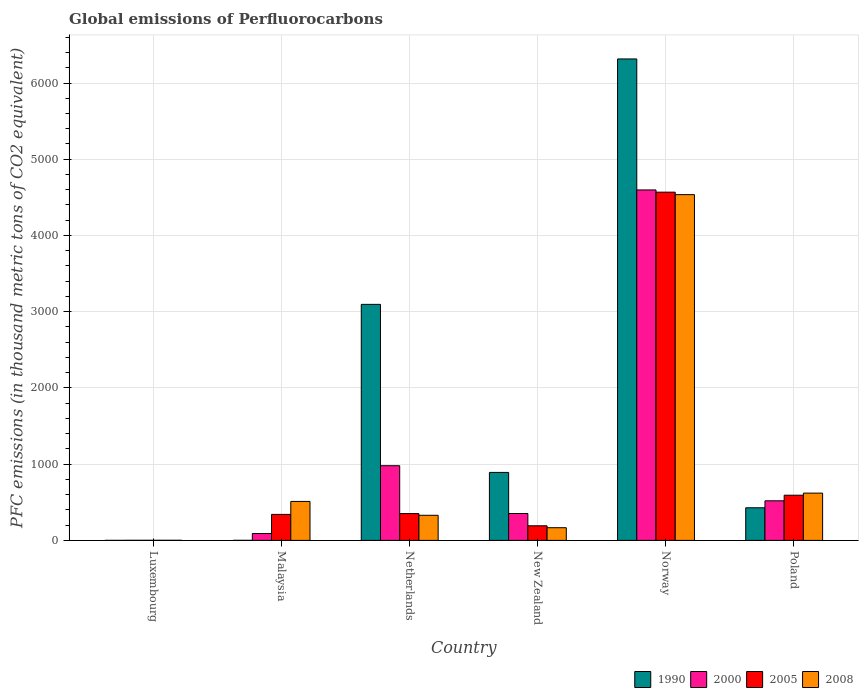How many different coloured bars are there?
Your answer should be compact. 4. How many groups of bars are there?
Provide a succinct answer. 6. Are the number of bars on each tick of the X-axis equal?
Give a very brief answer. Yes. How many bars are there on the 6th tick from the left?
Offer a very short reply. 4. How many bars are there on the 6th tick from the right?
Your response must be concise. 4. What is the label of the 4th group of bars from the left?
Provide a succinct answer. New Zealand. In how many cases, is the number of bars for a given country not equal to the number of legend labels?
Give a very brief answer. 0. What is the global emissions of Perfluorocarbons in 2008 in Norway?
Offer a terse response. 4535.7. Across all countries, what is the maximum global emissions of Perfluorocarbons in 1990?
Your response must be concise. 6315.7. Across all countries, what is the minimum global emissions of Perfluorocarbons in 2000?
Provide a short and direct response. 1. In which country was the global emissions of Perfluorocarbons in 2008 minimum?
Your answer should be compact. Luxembourg. What is the total global emissions of Perfluorocarbons in 2005 in the graph?
Give a very brief answer. 6045.8. What is the difference between the global emissions of Perfluorocarbons in 2005 in Luxembourg and that in New Zealand?
Offer a very short reply. -190.5. What is the difference between the global emissions of Perfluorocarbons in 2005 in Malaysia and the global emissions of Perfluorocarbons in 2008 in Luxembourg?
Your answer should be very brief. 339.7. What is the average global emissions of Perfluorocarbons in 2005 per country?
Offer a very short reply. 1007.63. What is the difference between the global emissions of Perfluorocarbons of/in 1990 and global emissions of Perfluorocarbons of/in 2008 in Poland?
Ensure brevity in your answer.  -192.3. What is the ratio of the global emissions of Perfluorocarbons in 2005 in Luxembourg to that in Malaysia?
Your response must be concise. 0. Is the difference between the global emissions of Perfluorocarbons in 1990 in Malaysia and Poland greater than the difference between the global emissions of Perfluorocarbons in 2008 in Malaysia and Poland?
Provide a short and direct response. No. What is the difference between the highest and the second highest global emissions of Perfluorocarbons in 1990?
Give a very brief answer. 2204.4. What is the difference between the highest and the lowest global emissions of Perfluorocarbons in 2000?
Your answer should be compact. 4596.3. Is the sum of the global emissions of Perfluorocarbons in 1990 in Luxembourg and Netherlands greater than the maximum global emissions of Perfluorocarbons in 2000 across all countries?
Your response must be concise. No. What does the 1st bar from the left in Poland represents?
Give a very brief answer. 1990. Is it the case that in every country, the sum of the global emissions of Perfluorocarbons in 2000 and global emissions of Perfluorocarbons in 2008 is greater than the global emissions of Perfluorocarbons in 2005?
Make the answer very short. Yes. How many bars are there?
Your answer should be very brief. 24. How many countries are there in the graph?
Offer a terse response. 6. What is the difference between two consecutive major ticks on the Y-axis?
Keep it short and to the point. 1000. Are the values on the major ticks of Y-axis written in scientific E-notation?
Offer a terse response. No. How are the legend labels stacked?
Make the answer very short. Horizontal. What is the title of the graph?
Keep it short and to the point. Global emissions of Perfluorocarbons. What is the label or title of the Y-axis?
Provide a short and direct response. PFC emissions (in thousand metric tons of CO2 equivalent). What is the PFC emissions (in thousand metric tons of CO2 equivalent) of 2008 in Luxembourg?
Provide a short and direct response. 1.2. What is the PFC emissions (in thousand metric tons of CO2 equivalent) of 2000 in Malaysia?
Your response must be concise. 90.1. What is the PFC emissions (in thousand metric tons of CO2 equivalent) in 2005 in Malaysia?
Provide a short and direct response. 340.9. What is the PFC emissions (in thousand metric tons of CO2 equivalent) of 2008 in Malaysia?
Make the answer very short. 511. What is the PFC emissions (in thousand metric tons of CO2 equivalent) of 1990 in Netherlands?
Give a very brief answer. 3096.2. What is the PFC emissions (in thousand metric tons of CO2 equivalent) in 2000 in Netherlands?
Offer a terse response. 979.5. What is the PFC emissions (in thousand metric tons of CO2 equivalent) of 2005 in Netherlands?
Keep it short and to the point. 351.4. What is the PFC emissions (in thousand metric tons of CO2 equivalent) in 2008 in Netherlands?
Give a very brief answer. 329.2. What is the PFC emissions (in thousand metric tons of CO2 equivalent) in 1990 in New Zealand?
Provide a short and direct response. 891.8. What is the PFC emissions (in thousand metric tons of CO2 equivalent) in 2000 in New Zealand?
Offer a very short reply. 352.6. What is the PFC emissions (in thousand metric tons of CO2 equivalent) of 2005 in New Zealand?
Your answer should be compact. 191.6. What is the PFC emissions (in thousand metric tons of CO2 equivalent) of 2008 in New Zealand?
Give a very brief answer. 166.4. What is the PFC emissions (in thousand metric tons of CO2 equivalent) of 1990 in Norway?
Provide a short and direct response. 6315.7. What is the PFC emissions (in thousand metric tons of CO2 equivalent) in 2000 in Norway?
Ensure brevity in your answer.  4597.3. What is the PFC emissions (in thousand metric tons of CO2 equivalent) of 2005 in Norway?
Give a very brief answer. 4568.1. What is the PFC emissions (in thousand metric tons of CO2 equivalent) in 2008 in Norway?
Ensure brevity in your answer.  4535.7. What is the PFC emissions (in thousand metric tons of CO2 equivalent) in 1990 in Poland?
Your answer should be very brief. 427.8. What is the PFC emissions (in thousand metric tons of CO2 equivalent) in 2000 in Poland?
Your answer should be compact. 519.3. What is the PFC emissions (in thousand metric tons of CO2 equivalent) of 2005 in Poland?
Provide a short and direct response. 592.7. What is the PFC emissions (in thousand metric tons of CO2 equivalent) in 2008 in Poland?
Offer a very short reply. 620.1. Across all countries, what is the maximum PFC emissions (in thousand metric tons of CO2 equivalent) in 1990?
Provide a succinct answer. 6315.7. Across all countries, what is the maximum PFC emissions (in thousand metric tons of CO2 equivalent) of 2000?
Give a very brief answer. 4597.3. Across all countries, what is the maximum PFC emissions (in thousand metric tons of CO2 equivalent) of 2005?
Offer a terse response. 4568.1. Across all countries, what is the maximum PFC emissions (in thousand metric tons of CO2 equivalent) in 2008?
Ensure brevity in your answer.  4535.7. Across all countries, what is the minimum PFC emissions (in thousand metric tons of CO2 equivalent) in 1990?
Give a very brief answer. 0.1. Across all countries, what is the minimum PFC emissions (in thousand metric tons of CO2 equivalent) in 2000?
Keep it short and to the point. 1. Across all countries, what is the minimum PFC emissions (in thousand metric tons of CO2 equivalent) of 2005?
Provide a short and direct response. 1.1. What is the total PFC emissions (in thousand metric tons of CO2 equivalent) in 1990 in the graph?
Provide a short and direct response. 1.07e+04. What is the total PFC emissions (in thousand metric tons of CO2 equivalent) of 2000 in the graph?
Make the answer very short. 6539.8. What is the total PFC emissions (in thousand metric tons of CO2 equivalent) in 2005 in the graph?
Your response must be concise. 6045.8. What is the total PFC emissions (in thousand metric tons of CO2 equivalent) in 2008 in the graph?
Provide a short and direct response. 6163.6. What is the difference between the PFC emissions (in thousand metric tons of CO2 equivalent) of 2000 in Luxembourg and that in Malaysia?
Your answer should be very brief. -89.1. What is the difference between the PFC emissions (in thousand metric tons of CO2 equivalent) in 2005 in Luxembourg and that in Malaysia?
Make the answer very short. -339.8. What is the difference between the PFC emissions (in thousand metric tons of CO2 equivalent) of 2008 in Luxembourg and that in Malaysia?
Provide a short and direct response. -509.8. What is the difference between the PFC emissions (in thousand metric tons of CO2 equivalent) of 1990 in Luxembourg and that in Netherlands?
Provide a short and direct response. -3096.1. What is the difference between the PFC emissions (in thousand metric tons of CO2 equivalent) of 2000 in Luxembourg and that in Netherlands?
Make the answer very short. -978.5. What is the difference between the PFC emissions (in thousand metric tons of CO2 equivalent) in 2005 in Luxembourg and that in Netherlands?
Keep it short and to the point. -350.3. What is the difference between the PFC emissions (in thousand metric tons of CO2 equivalent) in 2008 in Luxembourg and that in Netherlands?
Offer a terse response. -328. What is the difference between the PFC emissions (in thousand metric tons of CO2 equivalent) in 1990 in Luxembourg and that in New Zealand?
Ensure brevity in your answer.  -891.7. What is the difference between the PFC emissions (in thousand metric tons of CO2 equivalent) of 2000 in Luxembourg and that in New Zealand?
Keep it short and to the point. -351.6. What is the difference between the PFC emissions (in thousand metric tons of CO2 equivalent) of 2005 in Luxembourg and that in New Zealand?
Offer a terse response. -190.5. What is the difference between the PFC emissions (in thousand metric tons of CO2 equivalent) in 2008 in Luxembourg and that in New Zealand?
Your answer should be very brief. -165.2. What is the difference between the PFC emissions (in thousand metric tons of CO2 equivalent) of 1990 in Luxembourg and that in Norway?
Keep it short and to the point. -6315.6. What is the difference between the PFC emissions (in thousand metric tons of CO2 equivalent) of 2000 in Luxembourg and that in Norway?
Offer a terse response. -4596.3. What is the difference between the PFC emissions (in thousand metric tons of CO2 equivalent) of 2005 in Luxembourg and that in Norway?
Ensure brevity in your answer.  -4567. What is the difference between the PFC emissions (in thousand metric tons of CO2 equivalent) of 2008 in Luxembourg and that in Norway?
Keep it short and to the point. -4534.5. What is the difference between the PFC emissions (in thousand metric tons of CO2 equivalent) of 1990 in Luxembourg and that in Poland?
Your answer should be compact. -427.7. What is the difference between the PFC emissions (in thousand metric tons of CO2 equivalent) in 2000 in Luxembourg and that in Poland?
Provide a short and direct response. -518.3. What is the difference between the PFC emissions (in thousand metric tons of CO2 equivalent) of 2005 in Luxembourg and that in Poland?
Make the answer very short. -591.6. What is the difference between the PFC emissions (in thousand metric tons of CO2 equivalent) of 2008 in Luxembourg and that in Poland?
Give a very brief answer. -618.9. What is the difference between the PFC emissions (in thousand metric tons of CO2 equivalent) of 1990 in Malaysia and that in Netherlands?
Your answer should be very brief. -3095.6. What is the difference between the PFC emissions (in thousand metric tons of CO2 equivalent) in 2000 in Malaysia and that in Netherlands?
Offer a very short reply. -889.4. What is the difference between the PFC emissions (in thousand metric tons of CO2 equivalent) of 2005 in Malaysia and that in Netherlands?
Provide a short and direct response. -10.5. What is the difference between the PFC emissions (in thousand metric tons of CO2 equivalent) of 2008 in Malaysia and that in Netherlands?
Ensure brevity in your answer.  181.8. What is the difference between the PFC emissions (in thousand metric tons of CO2 equivalent) in 1990 in Malaysia and that in New Zealand?
Your response must be concise. -891.2. What is the difference between the PFC emissions (in thousand metric tons of CO2 equivalent) in 2000 in Malaysia and that in New Zealand?
Offer a very short reply. -262.5. What is the difference between the PFC emissions (in thousand metric tons of CO2 equivalent) of 2005 in Malaysia and that in New Zealand?
Provide a short and direct response. 149.3. What is the difference between the PFC emissions (in thousand metric tons of CO2 equivalent) of 2008 in Malaysia and that in New Zealand?
Offer a very short reply. 344.6. What is the difference between the PFC emissions (in thousand metric tons of CO2 equivalent) in 1990 in Malaysia and that in Norway?
Provide a short and direct response. -6315.1. What is the difference between the PFC emissions (in thousand metric tons of CO2 equivalent) of 2000 in Malaysia and that in Norway?
Your answer should be very brief. -4507.2. What is the difference between the PFC emissions (in thousand metric tons of CO2 equivalent) of 2005 in Malaysia and that in Norway?
Offer a terse response. -4227.2. What is the difference between the PFC emissions (in thousand metric tons of CO2 equivalent) in 2008 in Malaysia and that in Norway?
Your answer should be compact. -4024.7. What is the difference between the PFC emissions (in thousand metric tons of CO2 equivalent) of 1990 in Malaysia and that in Poland?
Make the answer very short. -427.2. What is the difference between the PFC emissions (in thousand metric tons of CO2 equivalent) in 2000 in Malaysia and that in Poland?
Your response must be concise. -429.2. What is the difference between the PFC emissions (in thousand metric tons of CO2 equivalent) in 2005 in Malaysia and that in Poland?
Keep it short and to the point. -251.8. What is the difference between the PFC emissions (in thousand metric tons of CO2 equivalent) in 2008 in Malaysia and that in Poland?
Make the answer very short. -109.1. What is the difference between the PFC emissions (in thousand metric tons of CO2 equivalent) of 1990 in Netherlands and that in New Zealand?
Offer a very short reply. 2204.4. What is the difference between the PFC emissions (in thousand metric tons of CO2 equivalent) in 2000 in Netherlands and that in New Zealand?
Offer a very short reply. 626.9. What is the difference between the PFC emissions (in thousand metric tons of CO2 equivalent) of 2005 in Netherlands and that in New Zealand?
Offer a very short reply. 159.8. What is the difference between the PFC emissions (in thousand metric tons of CO2 equivalent) of 2008 in Netherlands and that in New Zealand?
Make the answer very short. 162.8. What is the difference between the PFC emissions (in thousand metric tons of CO2 equivalent) of 1990 in Netherlands and that in Norway?
Your response must be concise. -3219.5. What is the difference between the PFC emissions (in thousand metric tons of CO2 equivalent) in 2000 in Netherlands and that in Norway?
Provide a short and direct response. -3617.8. What is the difference between the PFC emissions (in thousand metric tons of CO2 equivalent) of 2005 in Netherlands and that in Norway?
Provide a succinct answer. -4216.7. What is the difference between the PFC emissions (in thousand metric tons of CO2 equivalent) of 2008 in Netherlands and that in Norway?
Offer a terse response. -4206.5. What is the difference between the PFC emissions (in thousand metric tons of CO2 equivalent) of 1990 in Netherlands and that in Poland?
Give a very brief answer. 2668.4. What is the difference between the PFC emissions (in thousand metric tons of CO2 equivalent) of 2000 in Netherlands and that in Poland?
Make the answer very short. 460.2. What is the difference between the PFC emissions (in thousand metric tons of CO2 equivalent) in 2005 in Netherlands and that in Poland?
Keep it short and to the point. -241.3. What is the difference between the PFC emissions (in thousand metric tons of CO2 equivalent) in 2008 in Netherlands and that in Poland?
Your response must be concise. -290.9. What is the difference between the PFC emissions (in thousand metric tons of CO2 equivalent) of 1990 in New Zealand and that in Norway?
Ensure brevity in your answer.  -5423.9. What is the difference between the PFC emissions (in thousand metric tons of CO2 equivalent) of 2000 in New Zealand and that in Norway?
Make the answer very short. -4244.7. What is the difference between the PFC emissions (in thousand metric tons of CO2 equivalent) in 2005 in New Zealand and that in Norway?
Your answer should be very brief. -4376.5. What is the difference between the PFC emissions (in thousand metric tons of CO2 equivalent) of 2008 in New Zealand and that in Norway?
Your response must be concise. -4369.3. What is the difference between the PFC emissions (in thousand metric tons of CO2 equivalent) of 1990 in New Zealand and that in Poland?
Offer a terse response. 464. What is the difference between the PFC emissions (in thousand metric tons of CO2 equivalent) in 2000 in New Zealand and that in Poland?
Provide a succinct answer. -166.7. What is the difference between the PFC emissions (in thousand metric tons of CO2 equivalent) of 2005 in New Zealand and that in Poland?
Offer a terse response. -401.1. What is the difference between the PFC emissions (in thousand metric tons of CO2 equivalent) of 2008 in New Zealand and that in Poland?
Keep it short and to the point. -453.7. What is the difference between the PFC emissions (in thousand metric tons of CO2 equivalent) of 1990 in Norway and that in Poland?
Offer a very short reply. 5887.9. What is the difference between the PFC emissions (in thousand metric tons of CO2 equivalent) of 2000 in Norway and that in Poland?
Ensure brevity in your answer.  4078. What is the difference between the PFC emissions (in thousand metric tons of CO2 equivalent) in 2005 in Norway and that in Poland?
Keep it short and to the point. 3975.4. What is the difference between the PFC emissions (in thousand metric tons of CO2 equivalent) of 2008 in Norway and that in Poland?
Keep it short and to the point. 3915.6. What is the difference between the PFC emissions (in thousand metric tons of CO2 equivalent) in 1990 in Luxembourg and the PFC emissions (in thousand metric tons of CO2 equivalent) in 2000 in Malaysia?
Ensure brevity in your answer.  -90. What is the difference between the PFC emissions (in thousand metric tons of CO2 equivalent) of 1990 in Luxembourg and the PFC emissions (in thousand metric tons of CO2 equivalent) of 2005 in Malaysia?
Make the answer very short. -340.8. What is the difference between the PFC emissions (in thousand metric tons of CO2 equivalent) in 1990 in Luxembourg and the PFC emissions (in thousand metric tons of CO2 equivalent) in 2008 in Malaysia?
Provide a short and direct response. -510.9. What is the difference between the PFC emissions (in thousand metric tons of CO2 equivalent) in 2000 in Luxembourg and the PFC emissions (in thousand metric tons of CO2 equivalent) in 2005 in Malaysia?
Make the answer very short. -339.9. What is the difference between the PFC emissions (in thousand metric tons of CO2 equivalent) in 2000 in Luxembourg and the PFC emissions (in thousand metric tons of CO2 equivalent) in 2008 in Malaysia?
Provide a short and direct response. -510. What is the difference between the PFC emissions (in thousand metric tons of CO2 equivalent) of 2005 in Luxembourg and the PFC emissions (in thousand metric tons of CO2 equivalent) of 2008 in Malaysia?
Provide a succinct answer. -509.9. What is the difference between the PFC emissions (in thousand metric tons of CO2 equivalent) of 1990 in Luxembourg and the PFC emissions (in thousand metric tons of CO2 equivalent) of 2000 in Netherlands?
Give a very brief answer. -979.4. What is the difference between the PFC emissions (in thousand metric tons of CO2 equivalent) in 1990 in Luxembourg and the PFC emissions (in thousand metric tons of CO2 equivalent) in 2005 in Netherlands?
Provide a short and direct response. -351.3. What is the difference between the PFC emissions (in thousand metric tons of CO2 equivalent) of 1990 in Luxembourg and the PFC emissions (in thousand metric tons of CO2 equivalent) of 2008 in Netherlands?
Give a very brief answer. -329.1. What is the difference between the PFC emissions (in thousand metric tons of CO2 equivalent) of 2000 in Luxembourg and the PFC emissions (in thousand metric tons of CO2 equivalent) of 2005 in Netherlands?
Offer a terse response. -350.4. What is the difference between the PFC emissions (in thousand metric tons of CO2 equivalent) in 2000 in Luxembourg and the PFC emissions (in thousand metric tons of CO2 equivalent) in 2008 in Netherlands?
Provide a succinct answer. -328.2. What is the difference between the PFC emissions (in thousand metric tons of CO2 equivalent) in 2005 in Luxembourg and the PFC emissions (in thousand metric tons of CO2 equivalent) in 2008 in Netherlands?
Ensure brevity in your answer.  -328.1. What is the difference between the PFC emissions (in thousand metric tons of CO2 equivalent) in 1990 in Luxembourg and the PFC emissions (in thousand metric tons of CO2 equivalent) in 2000 in New Zealand?
Make the answer very short. -352.5. What is the difference between the PFC emissions (in thousand metric tons of CO2 equivalent) of 1990 in Luxembourg and the PFC emissions (in thousand metric tons of CO2 equivalent) of 2005 in New Zealand?
Provide a short and direct response. -191.5. What is the difference between the PFC emissions (in thousand metric tons of CO2 equivalent) of 1990 in Luxembourg and the PFC emissions (in thousand metric tons of CO2 equivalent) of 2008 in New Zealand?
Your answer should be compact. -166.3. What is the difference between the PFC emissions (in thousand metric tons of CO2 equivalent) of 2000 in Luxembourg and the PFC emissions (in thousand metric tons of CO2 equivalent) of 2005 in New Zealand?
Ensure brevity in your answer.  -190.6. What is the difference between the PFC emissions (in thousand metric tons of CO2 equivalent) in 2000 in Luxembourg and the PFC emissions (in thousand metric tons of CO2 equivalent) in 2008 in New Zealand?
Make the answer very short. -165.4. What is the difference between the PFC emissions (in thousand metric tons of CO2 equivalent) of 2005 in Luxembourg and the PFC emissions (in thousand metric tons of CO2 equivalent) of 2008 in New Zealand?
Offer a very short reply. -165.3. What is the difference between the PFC emissions (in thousand metric tons of CO2 equivalent) in 1990 in Luxembourg and the PFC emissions (in thousand metric tons of CO2 equivalent) in 2000 in Norway?
Provide a succinct answer. -4597.2. What is the difference between the PFC emissions (in thousand metric tons of CO2 equivalent) of 1990 in Luxembourg and the PFC emissions (in thousand metric tons of CO2 equivalent) of 2005 in Norway?
Your response must be concise. -4568. What is the difference between the PFC emissions (in thousand metric tons of CO2 equivalent) of 1990 in Luxembourg and the PFC emissions (in thousand metric tons of CO2 equivalent) of 2008 in Norway?
Your answer should be compact. -4535.6. What is the difference between the PFC emissions (in thousand metric tons of CO2 equivalent) in 2000 in Luxembourg and the PFC emissions (in thousand metric tons of CO2 equivalent) in 2005 in Norway?
Your answer should be very brief. -4567.1. What is the difference between the PFC emissions (in thousand metric tons of CO2 equivalent) in 2000 in Luxembourg and the PFC emissions (in thousand metric tons of CO2 equivalent) in 2008 in Norway?
Make the answer very short. -4534.7. What is the difference between the PFC emissions (in thousand metric tons of CO2 equivalent) of 2005 in Luxembourg and the PFC emissions (in thousand metric tons of CO2 equivalent) of 2008 in Norway?
Offer a very short reply. -4534.6. What is the difference between the PFC emissions (in thousand metric tons of CO2 equivalent) of 1990 in Luxembourg and the PFC emissions (in thousand metric tons of CO2 equivalent) of 2000 in Poland?
Ensure brevity in your answer.  -519.2. What is the difference between the PFC emissions (in thousand metric tons of CO2 equivalent) in 1990 in Luxembourg and the PFC emissions (in thousand metric tons of CO2 equivalent) in 2005 in Poland?
Your answer should be compact. -592.6. What is the difference between the PFC emissions (in thousand metric tons of CO2 equivalent) of 1990 in Luxembourg and the PFC emissions (in thousand metric tons of CO2 equivalent) of 2008 in Poland?
Your answer should be compact. -620. What is the difference between the PFC emissions (in thousand metric tons of CO2 equivalent) of 2000 in Luxembourg and the PFC emissions (in thousand metric tons of CO2 equivalent) of 2005 in Poland?
Ensure brevity in your answer.  -591.7. What is the difference between the PFC emissions (in thousand metric tons of CO2 equivalent) of 2000 in Luxembourg and the PFC emissions (in thousand metric tons of CO2 equivalent) of 2008 in Poland?
Give a very brief answer. -619.1. What is the difference between the PFC emissions (in thousand metric tons of CO2 equivalent) in 2005 in Luxembourg and the PFC emissions (in thousand metric tons of CO2 equivalent) in 2008 in Poland?
Your answer should be compact. -619. What is the difference between the PFC emissions (in thousand metric tons of CO2 equivalent) of 1990 in Malaysia and the PFC emissions (in thousand metric tons of CO2 equivalent) of 2000 in Netherlands?
Offer a very short reply. -978.9. What is the difference between the PFC emissions (in thousand metric tons of CO2 equivalent) in 1990 in Malaysia and the PFC emissions (in thousand metric tons of CO2 equivalent) in 2005 in Netherlands?
Your answer should be very brief. -350.8. What is the difference between the PFC emissions (in thousand metric tons of CO2 equivalent) of 1990 in Malaysia and the PFC emissions (in thousand metric tons of CO2 equivalent) of 2008 in Netherlands?
Ensure brevity in your answer.  -328.6. What is the difference between the PFC emissions (in thousand metric tons of CO2 equivalent) in 2000 in Malaysia and the PFC emissions (in thousand metric tons of CO2 equivalent) in 2005 in Netherlands?
Make the answer very short. -261.3. What is the difference between the PFC emissions (in thousand metric tons of CO2 equivalent) of 2000 in Malaysia and the PFC emissions (in thousand metric tons of CO2 equivalent) of 2008 in Netherlands?
Give a very brief answer. -239.1. What is the difference between the PFC emissions (in thousand metric tons of CO2 equivalent) of 1990 in Malaysia and the PFC emissions (in thousand metric tons of CO2 equivalent) of 2000 in New Zealand?
Offer a terse response. -352. What is the difference between the PFC emissions (in thousand metric tons of CO2 equivalent) in 1990 in Malaysia and the PFC emissions (in thousand metric tons of CO2 equivalent) in 2005 in New Zealand?
Offer a very short reply. -191. What is the difference between the PFC emissions (in thousand metric tons of CO2 equivalent) of 1990 in Malaysia and the PFC emissions (in thousand metric tons of CO2 equivalent) of 2008 in New Zealand?
Ensure brevity in your answer.  -165.8. What is the difference between the PFC emissions (in thousand metric tons of CO2 equivalent) in 2000 in Malaysia and the PFC emissions (in thousand metric tons of CO2 equivalent) in 2005 in New Zealand?
Offer a terse response. -101.5. What is the difference between the PFC emissions (in thousand metric tons of CO2 equivalent) of 2000 in Malaysia and the PFC emissions (in thousand metric tons of CO2 equivalent) of 2008 in New Zealand?
Offer a very short reply. -76.3. What is the difference between the PFC emissions (in thousand metric tons of CO2 equivalent) of 2005 in Malaysia and the PFC emissions (in thousand metric tons of CO2 equivalent) of 2008 in New Zealand?
Provide a short and direct response. 174.5. What is the difference between the PFC emissions (in thousand metric tons of CO2 equivalent) in 1990 in Malaysia and the PFC emissions (in thousand metric tons of CO2 equivalent) in 2000 in Norway?
Offer a very short reply. -4596.7. What is the difference between the PFC emissions (in thousand metric tons of CO2 equivalent) in 1990 in Malaysia and the PFC emissions (in thousand metric tons of CO2 equivalent) in 2005 in Norway?
Your answer should be compact. -4567.5. What is the difference between the PFC emissions (in thousand metric tons of CO2 equivalent) in 1990 in Malaysia and the PFC emissions (in thousand metric tons of CO2 equivalent) in 2008 in Norway?
Your answer should be compact. -4535.1. What is the difference between the PFC emissions (in thousand metric tons of CO2 equivalent) of 2000 in Malaysia and the PFC emissions (in thousand metric tons of CO2 equivalent) of 2005 in Norway?
Offer a very short reply. -4478. What is the difference between the PFC emissions (in thousand metric tons of CO2 equivalent) in 2000 in Malaysia and the PFC emissions (in thousand metric tons of CO2 equivalent) in 2008 in Norway?
Give a very brief answer. -4445.6. What is the difference between the PFC emissions (in thousand metric tons of CO2 equivalent) of 2005 in Malaysia and the PFC emissions (in thousand metric tons of CO2 equivalent) of 2008 in Norway?
Provide a short and direct response. -4194.8. What is the difference between the PFC emissions (in thousand metric tons of CO2 equivalent) of 1990 in Malaysia and the PFC emissions (in thousand metric tons of CO2 equivalent) of 2000 in Poland?
Keep it short and to the point. -518.7. What is the difference between the PFC emissions (in thousand metric tons of CO2 equivalent) of 1990 in Malaysia and the PFC emissions (in thousand metric tons of CO2 equivalent) of 2005 in Poland?
Offer a very short reply. -592.1. What is the difference between the PFC emissions (in thousand metric tons of CO2 equivalent) in 1990 in Malaysia and the PFC emissions (in thousand metric tons of CO2 equivalent) in 2008 in Poland?
Give a very brief answer. -619.5. What is the difference between the PFC emissions (in thousand metric tons of CO2 equivalent) in 2000 in Malaysia and the PFC emissions (in thousand metric tons of CO2 equivalent) in 2005 in Poland?
Offer a very short reply. -502.6. What is the difference between the PFC emissions (in thousand metric tons of CO2 equivalent) of 2000 in Malaysia and the PFC emissions (in thousand metric tons of CO2 equivalent) of 2008 in Poland?
Provide a succinct answer. -530. What is the difference between the PFC emissions (in thousand metric tons of CO2 equivalent) of 2005 in Malaysia and the PFC emissions (in thousand metric tons of CO2 equivalent) of 2008 in Poland?
Offer a terse response. -279.2. What is the difference between the PFC emissions (in thousand metric tons of CO2 equivalent) of 1990 in Netherlands and the PFC emissions (in thousand metric tons of CO2 equivalent) of 2000 in New Zealand?
Provide a succinct answer. 2743.6. What is the difference between the PFC emissions (in thousand metric tons of CO2 equivalent) in 1990 in Netherlands and the PFC emissions (in thousand metric tons of CO2 equivalent) in 2005 in New Zealand?
Keep it short and to the point. 2904.6. What is the difference between the PFC emissions (in thousand metric tons of CO2 equivalent) of 1990 in Netherlands and the PFC emissions (in thousand metric tons of CO2 equivalent) of 2008 in New Zealand?
Ensure brevity in your answer.  2929.8. What is the difference between the PFC emissions (in thousand metric tons of CO2 equivalent) of 2000 in Netherlands and the PFC emissions (in thousand metric tons of CO2 equivalent) of 2005 in New Zealand?
Make the answer very short. 787.9. What is the difference between the PFC emissions (in thousand metric tons of CO2 equivalent) of 2000 in Netherlands and the PFC emissions (in thousand metric tons of CO2 equivalent) of 2008 in New Zealand?
Provide a short and direct response. 813.1. What is the difference between the PFC emissions (in thousand metric tons of CO2 equivalent) of 2005 in Netherlands and the PFC emissions (in thousand metric tons of CO2 equivalent) of 2008 in New Zealand?
Make the answer very short. 185. What is the difference between the PFC emissions (in thousand metric tons of CO2 equivalent) of 1990 in Netherlands and the PFC emissions (in thousand metric tons of CO2 equivalent) of 2000 in Norway?
Make the answer very short. -1501.1. What is the difference between the PFC emissions (in thousand metric tons of CO2 equivalent) of 1990 in Netherlands and the PFC emissions (in thousand metric tons of CO2 equivalent) of 2005 in Norway?
Your answer should be compact. -1471.9. What is the difference between the PFC emissions (in thousand metric tons of CO2 equivalent) in 1990 in Netherlands and the PFC emissions (in thousand metric tons of CO2 equivalent) in 2008 in Norway?
Provide a succinct answer. -1439.5. What is the difference between the PFC emissions (in thousand metric tons of CO2 equivalent) in 2000 in Netherlands and the PFC emissions (in thousand metric tons of CO2 equivalent) in 2005 in Norway?
Your answer should be compact. -3588.6. What is the difference between the PFC emissions (in thousand metric tons of CO2 equivalent) in 2000 in Netherlands and the PFC emissions (in thousand metric tons of CO2 equivalent) in 2008 in Norway?
Offer a terse response. -3556.2. What is the difference between the PFC emissions (in thousand metric tons of CO2 equivalent) of 2005 in Netherlands and the PFC emissions (in thousand metric tons of CO2 equivalent) of 2008 in Norway?
Offer a terse response. -4184.3. What is the difference between the PFC emissions (in thousand metric tons of CO2 equivalent) of 1990 in Netherlands and the PFC emissions (in thousand metric tons of CO2 equivalent) of 2000 in Poland?
Keep it short and to the point. 2576.9. What is the difference between the PFC emissions (in thousand metric tons of CO2 equivalent) in 1990 in Netherlands and the PFC emissions (in thousand metric tons of CO2 equivalent) in 2005 in Poland?
Ensure brevity in your answer.  2503.5. What is the difference between the PFC emissions (in thousand metric tons of CO2 equivalent) of 1990 in Netherlands and the PFC emissions (in thousand metric tons of CO2 equivalent) of 2008 in Poland?
Ensure brevity in your answer.  2476.1. What is the difference between the PFC emissions (in thousand metric tons of CO2 equivalent) in 2000 in Netherlands and the PFC emissions (in thousand metric tons of CO2 equivalent) in 2005 in Poland?
Your response must be concise. 386.8. What is the difference between the PFC emissions (in thousand metric tons of CO2 equivalent) in 2000 in Netherlands and the PFC emissions (in thousand metric tons of CO2 equivalent) in 2008 in Poland?
Provide a succinct answer. 359.4. What is the difference between the PFC emissions (in thousand metric tons of CO2 equivalent) of 2005 in Netherlands and the PFC emissions (in thousand metric tons of CO2 equivalent) of 2008 in Poland?
Offer a very short reply. -268.7. What is the difference between the PFC emissions (in thousand metric tons of CO2 equivalent) in 1990 in New Zealand and the PFC emissions (in thousand metric tons of CO2 equivalent) in 2000 in Norway?
Offer a terse response. -3705.5. What is the difference between the PFC emissions (in thousand metric tons of CO2 equivalent) in 1990 in New Zealand and the PFC emissions (in thousand metric tons of CO2 equivalent) in 2005 in Norway?
Offer a terse response. -3676.3. What is the difference between the PFC emissions (in thousand metric tons of CO2 equivalent) of 1990 in New Zealand and the PFC emissions (in thousand metric tons of CO2 equivalent) of 2008 in Norway?
Give a very brief answer. -3643.9. What is the difference between the PFC emissions (in thousand metric tons of CO2 equivalent) in 2000 in New Zealand and the PFC emissions (in thousand metric tons of CO2 equivalent) in 2005 in Norway?
Ensure brevity in your answer.  -4215.5. What is the difference between the PFC emissions (in thousand metric tons of CO2 equivalent) of 2000 in New Zealand and the PFC emissions (in thousand metric tons of CO2 equivalent) of 2008 in Norway?
Offer a terse response. -4183.1. What is the difference between the PFC emissions (in thousand metric tons of CO2 equivalent) of 2005 in New Zealand and the PFC emissions (in thousand metric tons of CO2 equivalent) of 2008 in Norway?
Offer a terse response. -4344.1. What is the difference between the PFC emissions (in thousand metric tons of CO2 equivalent) of 1990 in New Zealand and the PFC emissions (in thousand metric tons of CO2 equivalent) of 2000 in Poland?
Your answer should be compact. 372.5. What is the difference between the PFC emissions (in thousand metric tons of CO2 equivalent) of 1990 in New Zealand and the PFC emissions (in thousand metric tons of CO2 equivalent) of 2005 in Poland?
Offer a terse response. 299.1. What is the difference between the PFC emissions (in thousand metric tons of CO2 equivalent) in 1990 in New Zealand and the PFC emissions (in thousand metric tons of CO2 equivalent) in 2008 in Poland?
Offer a terse response. 271.7. What is the difference between the PFC emissions (in thousand metric tons of CO2 equivalent) in 2000 in New Zealand and the PFC emissions (in thousand metric tons of CO2 equivalent) in 2005 in Poland?
Your answer should be compact. -240.1. What is the difference between the PFC emissions (in thousand metric tons of CO2 equivalent) of 2000 in New Zealand and the PFC emissions (in thousand metric tons of CO2 equivalent) of 2008 in Poland?
Ensure brevity in your answer.  -267.5. What is the difference between the PFC emissions (in thousand metric tons of CO2 equivalent) in 2005 in New Zealand and the PFC emissions (in thousand metric tons of CO2 equivalent) in 2008 in Poland?
Your response must be concise. -428.5. What is the difference between the PFC emissions (in thousand metric tons of CO2 equivalent) of 1990 in Norway and the PFC emissions (in thousand metric tons of CO2 equivalent) of 2000 in Poland?
Provide a short and direct response. 5796.4. What is the difference between the PFC emissions (in thousand metric tons of CO2 equivalent) of 1990 in Norway and the PFC emissions (in thousand metric tons of CO2 equivalent) of 2005 in Poland?
Give a very brief answer. 5723. What is the difference between the PFC emissions (in thousand metric tons of CO2 equivalent) of 1990 in Norway and the PFC emissions (in thousand metric tons of CO2 equivalent) of 2008 in Poland?
Your response must be concise. 5695.6. What is the difference between the PFC emissions (in thousand metric tons of CO2 equivalent) in 2000 in Norway and the PFC emissions (in thousand metric tons of CO2 equivalent) in 2005 in Poland?
Keep it short and to the point. 4004.6. What is the difference between the PFC emissions (in thousand metric tons of CO2 equivalent) of 2000 in Norway and the PFC emissions (in thousand metric tons of CO2 equivalent) of 2008 in Poland?
Your answer should be compact. 3977.2. What is the difference between the PFC emissions (in thousand metric tons of CO2 equivalent) in 2005 in Norway and the PFC emissions (in thousand metric tons of CO2 equivalent) in 2008 in Poland?
Offer a very short reply. 3948. What is the average PFC emissions (in thousand metric tons of CO2 equivalent) of 1990 per country?
Give a very brief answer. 1788.7. What is the average PFC emissions (in thousand metric tons of CO2 equivalent) of 2000 per country?
Your response must be concise. 1089.97. What is the average PFC emissions (in thousand metric tons of CO2 equivalent) in 2005 per country?
Offer a terse response. 1007.63. What is the average PFC emissions (in thousand metric tons of CO2 equivalent) in 2008 per country?
Your answer should be compact. 1027.27. What is the difference between the PFC emissions (in thousand metric tons of CO2 equivalent) in 1990 and PFC emissions (in thousand metric tons of CO2 equivalent) in 2005 in Luxembourg?
Your answer should be very brief. -1. What is the difference between the PFC emissions (in thousand metric tons of CO2 equivalent) in 2000 and PFC emissions (in thousand metric tons of CO2 equivalent) in 2005 in Luxembourg?
Make the answer very short. -0.1. What is the difference between the PFC emissions (in thousand metric tons of CO2 equivalent) in 1990 and PFC emissions (in thousand metric tons of CO2 equivalent) in 2000 in Malaysia?
Ensure brevity in your answer.  -89.5. What is the difference between the PFC emissions (in thousand metric tons of CO2 equivalent) in 1990 and PFC emissions (in thousand metric tons of CO2 equivalent) in 2005 in Malaysia?
Provide a succinct answer. -340.3. What is the difference between the PFC emissions (in thousand metric tons of CO2 equivalent) in 1990 and PFC emissions (in thousand metric tons of CO2 equivalent) in 2008 in Malaysia?
Make the answer very short. -510.4. What is the difference between the PFC emissions (in thousand metric tons of CO2 equivalent) in 2000 and PFC emissions (in thousand metric tons of CO2 equivalent) in 2005 in Malaysia?
Your response must be concise. -250.8. What is the difference between the PFC emissions (in thousand metric tons of CO2 equivalent) of 2000 and PFC emissions (in thousand metric tons of CO2 equivalent) of 2008 in Malaysia?
Keep it short and to the point. -420.9. What is the difference between the PFC emissions (in thousand metric tons of CO2 equivalent) in 2005 and PFC emissions (in thousand metric tons of CO2 equivalent) in 2008 in Malaysia?
Give a very brief answer. -170.1. What is the difference between the PFC emissions (in thousand metric tons of CO2 equivalent) in 1990 and PFC emissions (in thousand metric tons of CO2 equivalent) in 2000 in Netherlands?
Offer a terse response. 2116.7. What is the difference between the PFC emissions (in thousand metric tons of CO2 equivalent) in 1990 and PFC emissions (in thousand metric tons of CO2 equivalent) in 2005 in Netherlands?
Provide a short and direct response. 2744.8. What is the difference between the PFC emissions (in thousand metric tons of CO2 equivalent) of 1990 and PFC emissions (in thousand metric tons of CO2 equivalent) of 2008 in Netherlands?
Your answer should be compact. 2767. What is the difference between the PFC emissions (in thousand metric tons of CO2 equivalent) of 2000 and PFC emissions (in thousand metric tons of CO2 equivalent) of 2005 in Netherlands?
Offer a very short reply. 628.1. What is the difference between the PFC emissions (in thousand metric tons of CO2 equivalent) of 2000 and PFC emissions (in thousand metric tons of CO2 equivalent) of 2008 in Netherlands?
Offer a terse response. 650.3. What is the difference between the PFC emissions (in thousand metric tons of CO2 equivalent) in 2005 and PFC emissions (in thousand metric tons of CO2 equivalent) in 2008 in Netherlands?
Your answer should be very brief. 22.2. What is the difference between the PFC emissions (in thousand metric tons of CO2 equivalent) of 1990 and PFC emissions (in thousand metric tons of CO2 equivalent) of 2000 in New Zealand?
Provide a succinct answer. 539.2. What is the difference between the PFC emissions (in thousand metric tons of CO2 equivalent) of 1990 and PFC emissions (in thousand metric tons of CO2 equivalent) of 2005 in New Zealand?
Your response must be concise. 700.2. What is the difference between the PFC emissions (in thousand metric tons of CO2 equivalent) in 1990 and PFC emissions (in thousand metric tons of CO2 equivalent) in 2008 in New Zealand?
Your answer should be compact. 725.4. What is the difference between the PFC emissions (in thousand metric tons of CO2 equivalent) of 2000 and PFC emissions (in thousand metric tons of CO2 equivalent) of 2005 in New Zealand?
Ensure brevity in your answer.  161. What is the difference between the PFC emissions (in thousand metric tons of CO2 equivalent) of 2000 and PFC emissions (in thousand metric tons of CO2 equivalent) of 2008 in New Zealand?
Provide a succinct answer. 186.2. What is the difference between the PFC emissions (in thousand metric tons of CO2 equivalent) of 2005 and PFC emissions (in thousand metric tons of CO2 equivalent) of 2008 in New Zealand?
Keep it short and to the point. 25.2. What is the difference between the PFC emissions (in thousand metric tons of CO2 equivalent) in 1990 and PFC emissions (in thousand metric tons of CO2 equivalent) in 2000 in Norway?
Your answer should be very brief. 1718.4. What is the difference between the PFC emissions (in thousand metric tons of CO2 equivalent) of 1990 and PFC emissions (in thousand metric tons of CO2 equivalent) of 2005 in Norway?
Your answer should be very brief. 1747.6. What is the difference between the PFC emissions (in thousand metric tons of CO2 equivalent) in 1990 and PFC emissions (in thousand metric tons of CO2 equivalent) in 2008 in Norway?
Your response must be concise. 1780. What is the difference between the PFC emissions (in thousand metric tons of CO2 equivalent) in 2000 and PFC emissions (in thousand metric tons of CO2 equivalent) in 2005 in Norway?
Give a very brief answer. 29.2. What is the difference between the PFC emissions (in thousand metric tons of CO2 equivalent) of 2000 and PFC emissions (in thousand metric tons of CO2 equivalent) of 2008 in Norway?
Keep it short and to the point. 61.6. What is the difference between the PFC emissions (in thousand metric tons of CO2 equivalent) of 2005 and PFC emissions (in thousand metric tons of CO2 equivalent) of 2008 in Norway?
Ensure brevity in your answer.  32.4. What is the difference between the PFC emissions (in thousand metric tons of CO2 equivalent) of 1990 and PFC emissions (in thousand metric tons of CO2 equivalent) of 2000 in Poland?
Your answer should be compact. -91.5. What is the difference between the PFC emissions (in thousand metric tons of CO2 equivalent) of 1990 and PFC emissions (in thousand metric tons of CO2 equivalent) of 2005 in Poland?
Keep it short and to the point. -164.9. What is the difference between the PFC emissions (in thousand metric tons of CO2 equivalent) of 1990 and PFC emissions (in thousand metric tons of CO2 equivalent) of 2008 in Poland?
Your answer should be compact. -192.3. What is the difference between the PFC emissions (in thousand metric tons of CO2 equivalent) of 2000 and PFC emissions (in thousand metric tons of CO2 equivalent) of 2005 in Poland?
Keep it short and to the point. -73.4. What is the difference between the PFC emissions (in thousand metric tons of CO2 equivalent) of 2000 and PFC emissions (in thousand metric tons of CO2 equivalent) of 2008 in Poland?
Ensure brevity in your answer.  -100.8. What is the difference between the PFC emissions (in thousand metric tons of CO2 equivalent) in 2005 and PFC emissions (in thousand metric tons of CO2 equivalent) in 2008 in Poland?
Make the answer very short. -27.4. What is the ratio of the PFC emissions (in thousand metric tons of CO2 equivalent) of 2000 in Luxembourg to that in Malaysia?
Make the answer very short. 0.01. What is the ratio of the PFC emissions (in thousand metric tons of CO2 equivalent) of 2005 in Luxembourg to that in Malaysia?
Your answer should be compact. 0. What is the ratio of the PFC emissions (in thousand metric tons of CO2 equivalent) of 2008 in Luxembourg to that in Malaysia?
Your answer should be compact. 0. What is the ratio of the PFC emissions (in thousand metric tons of CO2 equivalent) in 1990 in Luxembourg to that in Netherlands?
Ensure brevity in your answer.  0. What is the ratio of the PFC emissions (in thousand metric tons of CO2 equivalent) in 2000 in Luxembourg to that in Netherlands?
Offer a terse response. 0. What is the ratio of the PFC emissions (in thousand metric tons of CO2 equivalent) in 2005 in Luxembourg to that in Netherlands?
Provide a succinct answer. 0. What is the ratio of the PFC emissions (in thousand metric tons of CO2 equivalent) of 2008 in Luxembourg to that in Netherlands?
Make the answer very short. 0. What is the ratio of the PFC emissions (in thousand metric tons of CO2 equivalent) in 1990 in Luxembourg to that in New Zealand?
Your answer should be very brief. 0. What is the ratio of the PFC emissions (in thousand metric tons of CO2 equivalent) of 2000 in Luxembourg to that in New Zealand?
Ensure brevity in your answer.  0. What is the ratio of the PFC emissions (in thousand metric tons of CO2 equivalent) in 2005 in Luxembourg to that in New Zealand?
Provide a succinct answer. 0.01. What is the ratio of the PFC emissions (in thousand metric tons of CO2 equivalent) of 2008 in Luxembourg to that in New Zealand?
Make the answer very short. 0.01. What is the ratio of the PFC emissions (in thousand metric tons of CO2 equivalent) of 2000 in Luxembourg to that in Norway?
Your answer should be compact. 0. What is the ratio of the PFC emissions (in thousand metric tons of CO2 equivalent) of 2008 in Luxembourg to that in Norway?
Your answer should be compact. 0. What is the ratio of the PFC emissions (in thousand metric tons of CO2 equivalent) of 1990 in Luxembourg to that in Poland?
Provide a succinct answer. 0. What is the ratio of the PFC emissions (in thousand metric tons of CO2 equivalent) of 2000 in Luxembourg to that in Poland?
Make the answer very short. 0. What is the ratio of the PFC emissions (in thousand metric tons of CO2 equivalent) in 2005 in Luxembourg to that in Poland?
Give a very brief answer. 0. What is the ratio of the PFC emissions (in thousand metric tons of CO2 equivalent) of 2008 in Luxembourg to that in Poland?
Provide a succinct answer. 0. What is the ratio of the PFC emissions (in thousand metric tons of CO2 equivalent) of 2000 in Malaysia to that in Netherlands?
Your answer should be very brief. 0.09. What is the ratio of the PFC emissions (in thousand metric tons of CO2 equivalent) of 2005 in Malaysia to that in Netherlands?
Your answer should be compact. 0.97. What is the ratio of the PFC emissions (in thousand metric tons of CO2 equivalent) of 2008 in Malaysia to that in Netherlands?
Your answer should be compact. 1.55. What is the ratio of the PFC emissions (in thousand metric tons of CO2 equivalent) of 1990 in Malaysia to that in New Zealand?
Offer a very short reply. 0. What is the ratio of the PFC emissions (in thousand metric tons of CO2 equivalent) in 2000 in Malaysia to that in New Zealand?
Keep it short and to the point. 0.26. What is the ratio of the PFC emissions (in thousand metric tons of CO2 equivalent) in 2005 in Malaysia to that in New Zealand?
Give a very brief answer. 1.78. What is the ratio of the PFC emissions (in thousand metric tons of CO2 equivalent) of 2008 in Malaysia to that in New Zealand?
Keep it short and to the point. 3.07. What is the ratio of the PFC emissions (in thousand metric tons of CO2 equivalent) of 1990 in Malaysia to that in Norway?
Offer a very short reply. 0. What is the ratio of the PFC emissions (in thousand metric tons of CO2 equivalent) of 2000 in Malaysia to that in Norway?
Offer a very short reply. 0.02. What is the ratio of the PFC emissions (in thousand metric tons of CO2 equivalent) of 2005 in Malaysia to that in Norway?
Offer a terse response. 0.07. What is the ratio of the PFC emissions (in thousand metric tons of CO2 equivalent) in 2008 in Malaysia to that in Norway?
Your answer should be compact. 0.11. What is the ratio of the PFC emissions (in thousand metric tons of CO2 equivalent) in 1990 in Malaysia to that in Poland?
Provide a short and direct response. 0. What is the ratio of the PFC emissions (in thousand metric tons of CO2 equivalent) of 2000 in Malaysia to that in Poland?
Provide a short and direct response. 0.17. What is the ratio of the PFC emissions (in thousand metric tons of CO2 equivalent) in 2005 in Malaysia to that in Poland?
Offer a terse response. 0.58. What is the ratio of the PFC emissions (in thousand metric tons of CO2 equivalent) in 2008 in Malaysia to that in Poland?
Your response must be concise. 0.82. What is the ratio of the PFC emissions (in thousand metric tons of CO2 equivalent) of 1990 in Netherlands to that in New Zealand?
Provide a succinct answer. 3.47. What is the ratio of the PFC emissions (in thousand metric tons of CO2 equivalent) of 2000 in Netherlands to that in New Zealand?
Your answer should be compact. 2.78. What is the ratio of the PFC emissions (in thousand metric tons of CO2 equivalent) in 2005 in Netherlands to that in New Zealand?
Provide a succinct answer. 1.83. What is the ratio of the PFC emissions (in thousand metric tons of CO2 equivalent) in 2008 in Netherlands to that in New Zealand?
Ensure brevity in your answer.  1.98. What is the ratio of the PFC emissions (in thousand metric tons of CO2 equivalent) of 1990 in Netherlands to that in Norway?
Your answer should be compact. 0.49. What is the ratio of the PFC emissions (in thousand metric tons of CO2 equivalent) in 2000 in Netherlands to that in Norway?
Ensure brevity in your answer.  0.21. What is the ratio of the PFC emissions (in thousand metric tons of CO2 equivalent) of 2005 in Netherlands to that in Norway?
Give a very brief answer. 0.08. What is the ratio of the PFC emissions (in thousand metric tons of CO2 equivalent) in 2008 in Netherlands to that in Norway?
Offer a very short reply. 0.07. What is the ratio of the PFC emissions (in thousand metric tons of CO2 equivalent) of 1990 in Netherlands to that in Poland?
Keep it short and to the point. 7.24. What is the ratio of the PFC emissions (in thousand metric tons of CO2 equivalent) in 2000 in Netherlands to that in Poland?
Give a very brief answer. 1.89. What is the ratio of the PFC emissions (in thousand metric tons of CO2 equivalent) of 2005 in Netherlands to that in Poland?
Offer a terse response. 0.59. What is the ratio of the PFC emissions (in thousand metric tons of CO2 equivalent) in 2008 in Netherlands to that in Poland?
Your answer should be compact. 0.53. What is the ratio of the PFC emissions (in thousand metric tons of CO2 equivalent) of 1990 in New Zealand to that in Norway?
Provide a succinct answer. 0.14. What is the ratio of the PFC emissions (in thousand metric tons of CO2 equivalent) of 2000 in New Zealand to that in Norway?
Provide a short and direct response. 0.08. What is the ratio of the PFC emissions (in thousand metric tons of CO2 equivalent) in 2005 in New Zealand to that in Norway?
Your response must be concise. 0.04. What is the ratio of the PFC emissions (in thousand metric tons of CO2 equivalent) in 2008 in New Zealand to that in Norway?
Offer a very short reply. 0.04. What is the ratio of the PFC emissions (in thousand metric tons of CO2 equivalent) in 1990 in New Zealand to that in Poland?
Provide a succinct answer. 2.08. What is the ratio of the PFC emissions (in thousand metric tons of CO2 equivalent) of 2000 in New Zealand to that in Poland?
Offer a terse response. 0.68. What is the ratio of the PFC emissions (in thousand metric tons of CO2 equivalent) in 2005 in New Zealand to that in Poland?
Ensure brevity in your answer.  0.32. What is the ratio of the PFC emissions (in thousand metric tons of CO2 equivalent) of 2008 in New Zealand to that in Poland?
Offer a terse response. 0.27. What is the ratio of the PFC emissions (in thousand metric tons of CO2 equivalent) of 1990 in Norway to that in Poland?
Your answer should be very brief. 14.76. What is the ratio of the PFC emissions (in thousand metric tons of CO2 equivalent) in 2000 in Norway to that in Poland?
Keep it short and to the point. 8.85. What is the ratio of the PFC emissions (in thousand metric tons of CO2 equivalent) in 2005 in Norway to that in Poland?
Make the answer very short. 7.71. What is the ratio of the PFC emissions (in thousand metric tons of CO2 equivalent) in 2008 in Norway to that in Poland?
Your answer should be very brief. 7.31. What is the difference between the highest and the second highest PFC emissions (in thousand metric tons of CO2 equivalent) in 1990?
Provide a short and direct response. 3219.5. What is the difference between the highest and the second highest PFC emissions (in thousand metric tons of CO2 equivalent) of 2000?
Provide a succinct answer. 3617.8. What is the difference between the highest and the second highest PFC emissions (in thousand metric tons of CO2 equivalent) in 2005?
Provide a short and direct response. 3975.4. What is the difference between the highest and the second highest PFC emissions (in thousand metric tons of CO2 equivalent) in 2008?
Keep it short and to the point. 3915.6. What is the difference between the highest and the lowest PFC emissions (in thousand metric tons of CO2 equivalent) of 1990?
Make the answer very short. 6315.6. What is the difference between the highest and the lowest PFC emissions (in thousand metric tons of CO2 equivalent) in 2000?
Ensure brevity in your answer.  4596.3. What is the difference between the highest and the lowest PFC emissions (in thousand metric tons of CO2 equivalent) of 2005?
Make the answer very short. 4567. What is the difference between the highest and the lowest PFC emissions (in thousand metric tons of CO2 equivalent) of 2008?
Ensure brevity in your answer.  4534.5. 